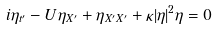<formula> <loc_0><loc_0><loc_500><loc_500>i \eta _ { t ^ { \prime } } - U \eta _ { X ^ { \prime } } + \eta _ { X ^ { \prime } X ^ { \prime } } + \kappa | \eta | ^ { 2 } \eta = 0</formula> 